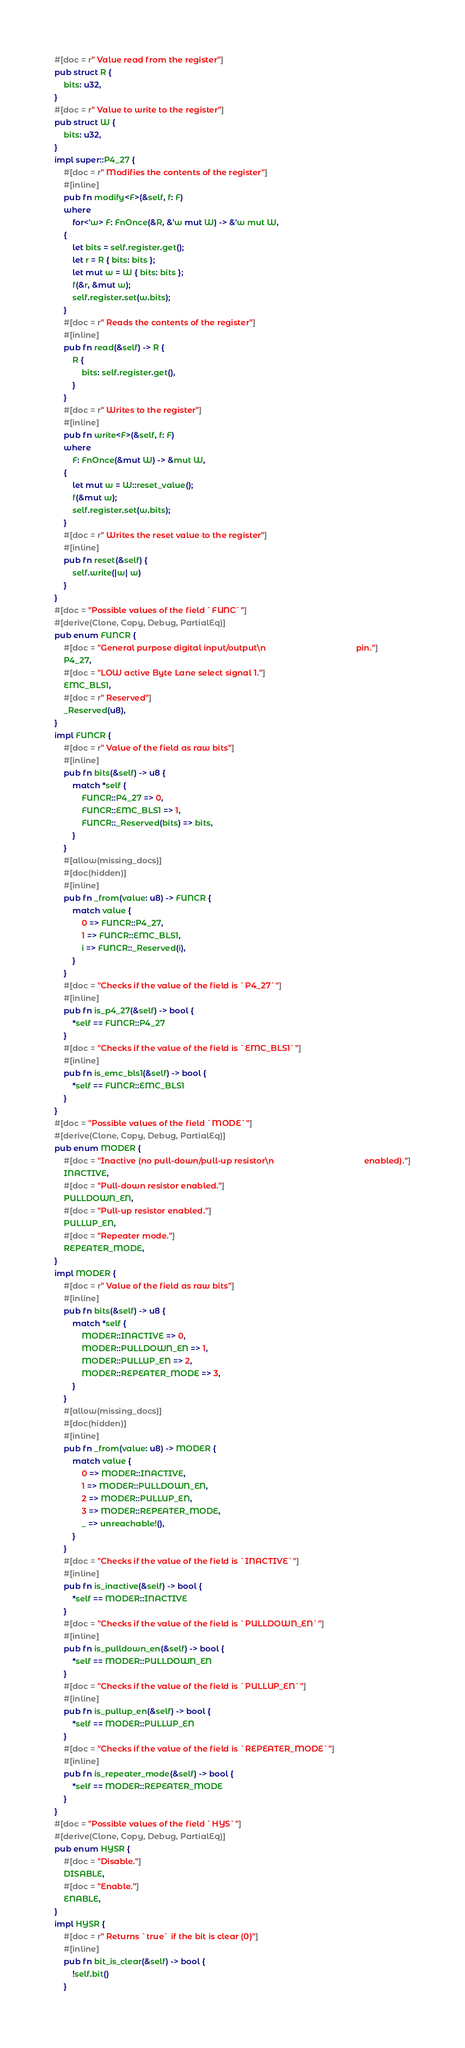<code> <loc_0><loc_0><loc_500><loc_500><_Rust_>#[doc = r" Value read from the register"]
pub struct R {
    bits: u32,
}
#[doc = r" Value to write to the register"]
pub struct W {
    bits: u32,
}
impl super::P4_27 {
    #[doc = r" Modifies the contents of the register"]
    #[inline]
    pub fn modify<F>(&self, f: F)
    where
        for<'w> F: FnOnce(&R, &'w mut W) -> &'w mut W,
    {
        let bits = self.register.get();
        let r = R { bits: bits };
        let mut w = W { bits: bits };
        f(&r, &mut w);
        self.register.set(w.bits);
    }
    #[doc = r" Reads the contents of the register"]
    #[inline]
    pub fn read(&self) -> R {
        R {
            bits: self.register.get(),
        }
    }
    #[doc = r" Writes to the register"]
    #[inline]
    pub fn write<F>(&self, f: F)
    where
        F: FnOnce(&mut W) -> &mut W,
    {
        let mut w = W::reset_value();
        f(&mut w);
        self.register.set(w.bits);
    }
    #[doc = r" Writes the reset value to the register"]
    #[inline]
    pub fn reset(&self) {
        self.write(|w| w)
    }
}
#[doc = "Possible values of the field `FUNC`"]
#[derive(Clone, Copy, Debug, PartialEq)]
pub enum FUNCR {
    #[doc = "General purpose digital input/output\n                                        pin."]
    P4_27,
    #[doc = "LOW active Byte Lane select signal 1."]
    EMC_BLS1,
    #[doc = r" Reserved"]
    _Reserved(u8),
}
impl FUNCR {
    #[doc = r" Value of the field as raw bits"]
    #[inline]
    pub fn bits(&self) -> u8 {
        match *self {
            FUNCR::P4_27 => 0,
            FUNCR::EMC_BLS1 => 1,
            FUNCR::_Reserved(bits) => bits,
        }
    }
    #[allow(missing_docs)]
    #[doc(hidden)]
    #[inline]
    pub fn _from(value: u8) -> FUNCR {
        match value {
            0 => FUNCR::P4_27,
            1 => FUNCR::EMC_BLS1,
            i => FUNCR::_Reserved(i),
        }
    }
    #[doc = "Checks if the value of the field is `P4_27`"]
    #[inline]
    pub fn is_p4_27(&self) -> bool {
        *self == FUNCR::P4_27
    }
    #[doc = "Checks if the value of the field is `EMC_BLS1`"]
    #[inline]
    pub fn is_emc_bls1(&self) -> bool {
        *self == FUNCR::EMC_BLS1
    }
}
#[doc = "Possible values of the field `MODE`"]
#[derive(Clone, Copy, Debug, PartialEq)]
pub enum MODER {
    #[doc = "Inactive (no pull-down/pull-up resistor\n                                        enabled)."]
    INACTIVE,
    #[doc = "Pull-down resistor enabled."]
    PULLDOWN_EN,
    #[doc = "Pull-up resistor enabled."]
    PULLUP_EN,
    #[doc = "Repeater mode."]
    REPEATER_MODE,
}
impl MODER {
    #[doc = r" Value of the field as raw bits"]
    #[inline]
    pub fn bits(&self) -> u8 {
        match *self {
            MODER::INACTIVE => 0,
            MODER::PULLDOWN_EN => 1,
            MODER::PULLUP_EN => 2,
            MODER::REPEATER_MODE => 3,
        }
    }
    #[allow(missing_docs)]
    #[doc(hidden)]
    #[inline]
    pub fn _from(value: u8) -> MODER {
        match value {
            0 => MODER::INACTIVE,
            1 => MODER::PULLDOWN_EN,
            2 => MODER::PULLUP_EN,
            3 => MODER::REPEATER_MODE,
            _ => unreachable!(),
        }
    }
    #[doc = "Checks if the value of the field is `INACTIVE`"]
    #[inline]
    pub fn is_inactive(&self) -> bool {
        *self == MODER::INACTIVE
    }
    #[doc = "Checks if the value of the field is `PULLDOWN_EN`"]
    #[inline]
    pub fn is_pulldown_en(&self) -> bool {
        *self == MODER::PULLDOWN_EN
    }
    #[doc = "Checks if the value of the field is `PULLUP_EN`"]
    #[inline]
    pub fn is_pullup_en(&self) -> bool {
        *self == MODER::PULLUP_EN
    }
    #[doc = "Checks if the value of the field is `REPEATER_MODE`"]
    #[inline]
    pub fn is_repeater_mode(&self) -> bool {
        *self == MODER::REPEATER_MODE
    }
}
#[doc = "Possible values of the field `HYS`"]
#[derive(Clone, Copy, Debug, PartialEq)]
pub enum HYSR {
    #[doc = "Disable."]
    DISABLE,
    #[doc = "Enable."]
    ENABLE,
}
impl HYSR {
    #[doc = r" Returns `true` if the bit is clear (0)"]
    #[inline]
    pub fn bit_is_clear(&self) -> bool {
        !self.bit()
    }</code> 